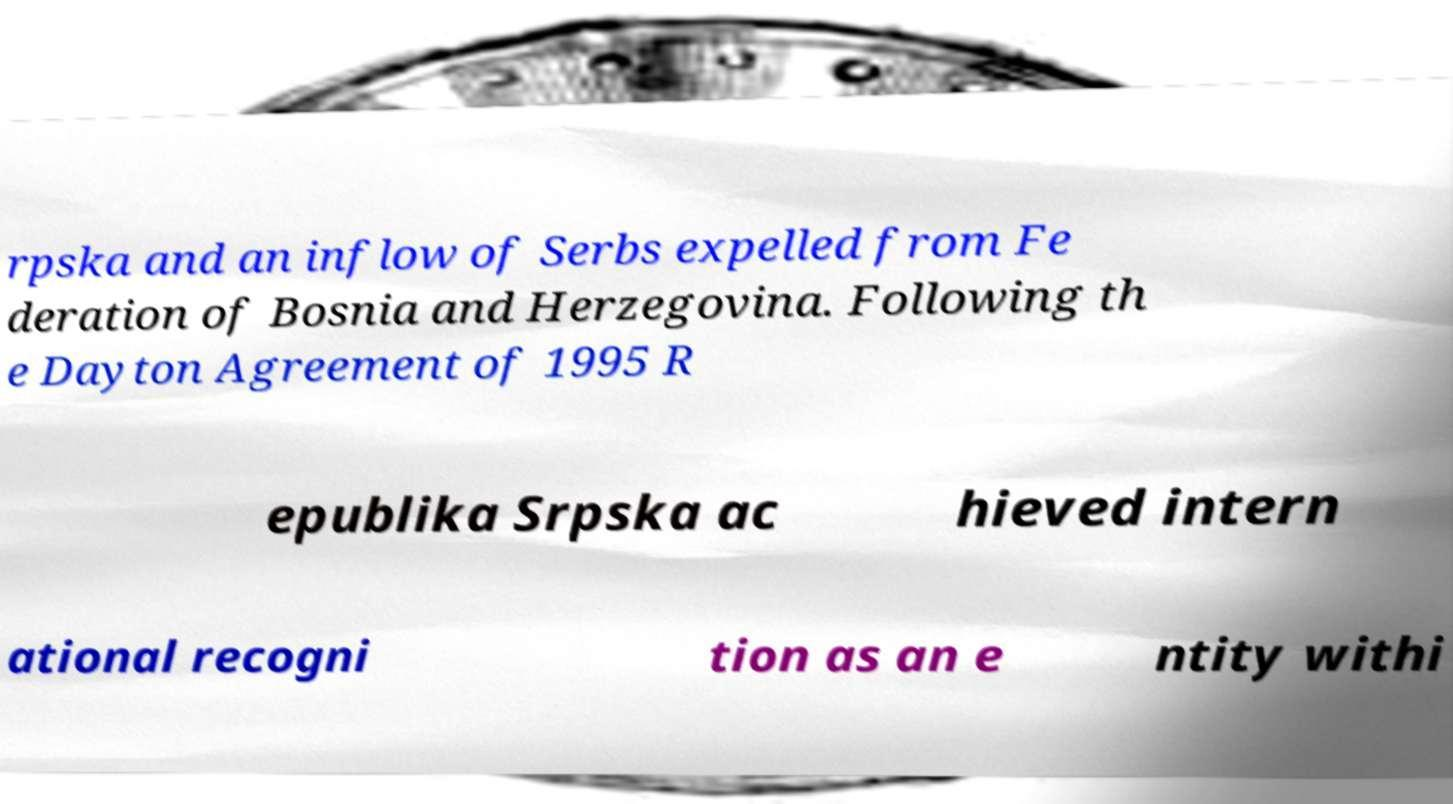Could you assist in decoding the text presented in this image and type it out clearly? rpska and an inflow of Serbs expelled from Fe deration of Bosnia and Herzegovina. Following th e Dayton Agreement of 1995 R epublika Srpska ac hieved intern ational recogni tion as an e ntity withi 